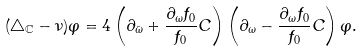<formula> <loc_0><loc_0><loc_500><loc_500>( \triangle _ { \mathbb { C } } - \nu ) \varphi = 4 \left ( \partial _ { \bar { \omega } } + \frac { \partial _ { \omega } f _ { 0 } } { f _ { 0 } } C \right ) \left ( \partial _ { \omega } - \frac { \partial _ { \omega } f _ { 0 } } { f _ { 0 } } C \right ) \varphi .</formula> 